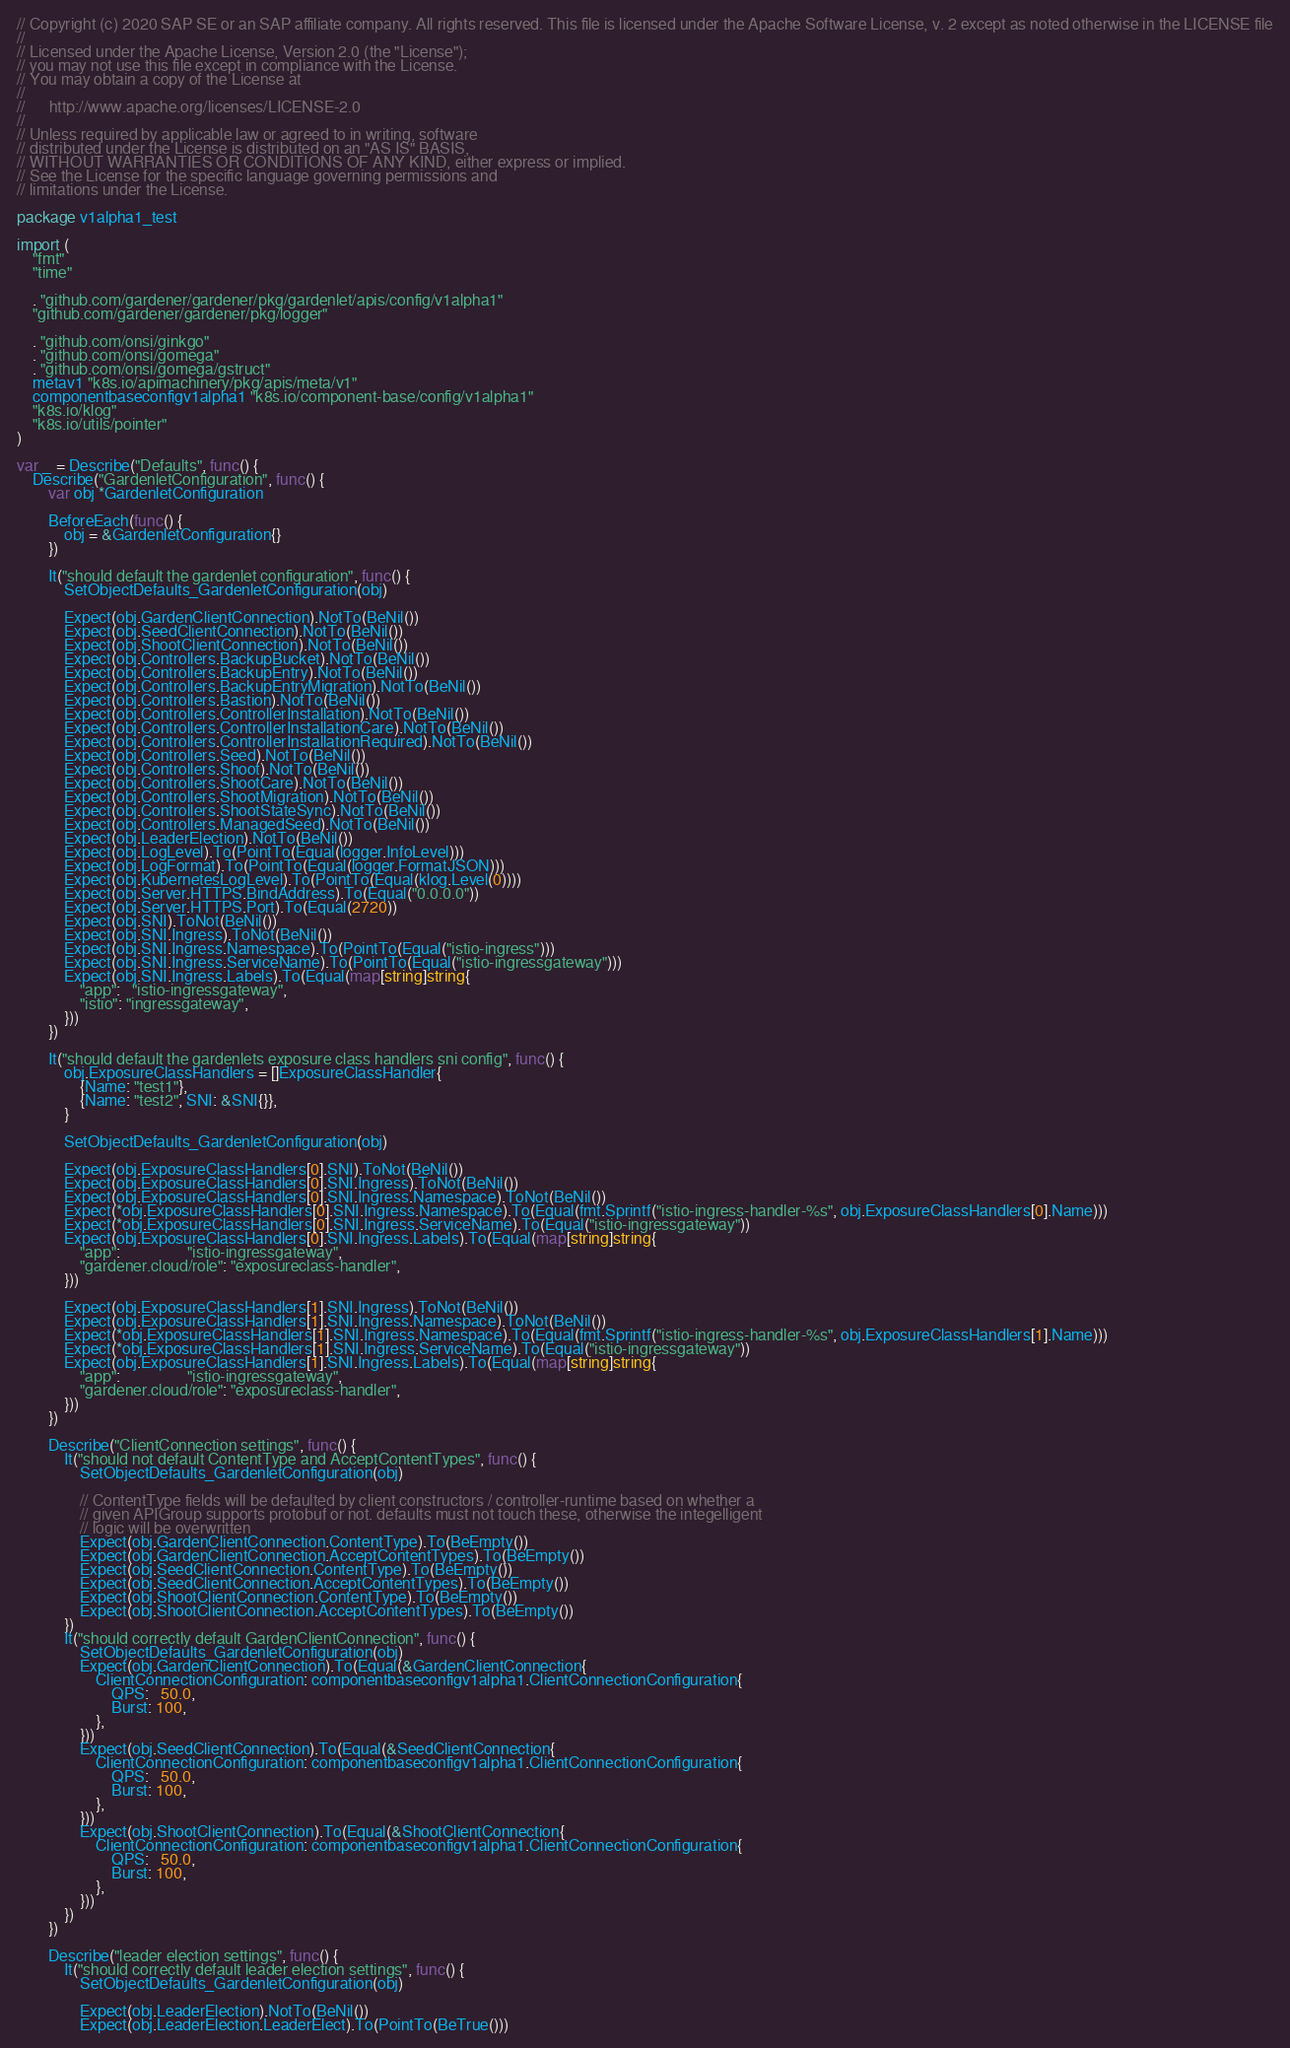Convert code to text. <code><loc_0><loc_0><loc_500><loc_500><_Go_>// Copyright (c) 2020 SAP SE or an SAP affiliate company. All rights reserved. This file is licensed under the Apache Software License, v. 2 except as noted otherwise in the LICENSE file
//
// Licensed under the Apache License, Version 2.0 (the "License");
// you may not use this file except in compliance with the License.
// You may obtain a copy of the License at
//
//      http://www.apache.org/licenses/LICENSE-2.0
//
// Unless required by applicable law or agreed to in writing, software
// distributed under the License is distributed on an "AS IS" BASIS,
// WITHOUT WARRANTIES OR CONDITIONS OF ANY KIND, either express or implied.
// See the License for the specific language governing permissions and
// limitations under the License.

package v1alpha1_test

import (
	"fmt"
	"time"

	. "github.com/gardener/gardener/pkg/gardenlet/apis/config/v1alpha1"
	"github.com/gardener/gardener/pkg/logger"

	. "github.com/onsi/ginkgo"
	. "github.com/onsi/gomega"
	. "github.com/onsi/gomega/gstruct"
	metav1 "k8s.io/apimachinery/pkg/apis/meta/v1"
	componentbaseconfigv1alpha1 "k8s.io/component-base/config/v1alpha1"
	"k8s.io/klog"
	"k8s.io/utils/pointer"
)

var _ = Describe("Defaults", func() {
	Describe("GardenletConfiguration", func() {
		var obj *GardenletConfiguration

		BeforeEach(func() {
			obj = &GardenletConfiguration{}
		})

		It("should default the gardenlet configuration", func() {
			SetObjectDefaults_GardenletConfiguration(obj)

			Expect(obj.GardenClientConnection).NotTo(BeNil())
			Expect(obj.SeedClientConnection).NotTo(BeNil())
			Expect(obj.ShootClientConnection).NotTo(BeNil())
			Expect(obj.Controllers.BackupBucket).NotTo(BeNil())
			Expect(obj.Controllers.BackupEntry).NotTo(BeNil())
			Expect(obj.Controllers.BackupEntryMigration).NotTo(BeNil())
			Expect(obj.Controllers.Bastion).NotTo(BeNil())
			Expect(obj.Controllers.ControllerInstallation).NotTo(BeNil())
			Expect(obj.Controllers.ControllerInstallationCare).NotTo(BeNil())
			Expect(obj.Controllers.ControllerInstallationRequired).NotTo(BeNil())
			Expect(obj.Controllers.Seed).NotTo(BeNil())
			Expect(obj.Controllers.Shoot).NotTo(BeNil())
			Expect(obj.Controllers.ShootCare).NotTo(BeNil())
			Expect(obj.Controllers.ShootMigration).NotTo(BeNil())
			Expect(obj.Controllers.ShootStateSync).NotTo(BeNil())
			Expect(obj.Controllers.ManagedSeed).NotTo(BeNil())
			Expect(obj.LeaderElection).NotTo(BeNil())
			Expect(obj.LogLevel).To(PointTo(Equal(logger.InfoLevel)))
			Expect(obj.LogFormat).To(PointTo(Equal(logger.FormatJSON)))
			Expect(obj.KubernetesLogLevel).To(PointTo(Equal(klog.Level(0))))
			Expect(obj.Server.HTTPS.BindAddress).To(Equal("0.0.0.0"))
			Expect(obj.Server.HTTPS.Port).To(Equal(2720))
			Expect(obj.SNI).ToNot(BeNil())
			Expect(obj.SNI.Ingress).ToNot(BeNil())
			Expect(obj.SNI.Ingress.Namespace).To(PointTo(Equal("istio-ingress")))
			Expect(obj.SNI.Ingress.ServiceName).To(PointTo(Equal("istio-ingressgateway")))
			Expect(obj.SNI.Ingress.Labels).To(Equal(map[string]string{
				"app":   "istio-ingressgateway",
				"istio": "ingressgateway",
			}))
		})

		It("should default the gardenlets exposure class handlers sni config", func() {
			obj.ExposureClassHandlers = []ExposureClassHandler{
				{Name: "test1"},
				{Name: "test2", SNI: &SNI{}},
			}

			SetObjectDefaults_GardenletConfiguration(obj)

			Expect(obj.ExposureClassHandlers[0].SNI).ToNot(BeNil())
			Expect(obj.ExposureClassHandlers[0].SNI.Ingress).ToNot(BeNil())
			Expect(obj.ExposureClassHandlers[0].SNI.Ingress.Namespace).ToNot(BeNil())
			Expect(*obj.ExposureClassHandlers[0].SNI.Ingress.Namespace).To(Equal(fmt.Sprintf("istio-ingress-handler-%s", obj.ExposureClassHandlers[0].Name)))
			Expect(*obj.ExposureClassHandlers[0].SNI.Ingress.ServiceName).To(Equal("istio-ingressgateway"))
			Expect(obj.ExposureClassHandlers[0].SNI.Ingress.Labels).To(Equal(map[string]string{
				"app":                 "istio-ingressgateway",
				"gardener.cloud/role": "exposureclass-handler",
			}))

			Expect(obj.ExposureClassHandlers[1].SNI.Ingress).ToNot(BeNil())
			Expect(obj.ExposureClassHandlers[1].SNI.Ingress.Namespace).ToNot(BeNil())
			Expect(*obj.ExposureClassHandlers[1].SNI.Ingress.Namespace).To(Equal(fmt.Sprintf("istio-ingress-handler-%s", obj.ExposureClassHandlers[1].Name)))
			Expect(*obj.ExposureClassHandlers[1].SNI.Ingress.ServiceName).To(Equal("istio-ingressgateway"))
			Expect(obj.ExposureClassHandlers[1].SNI.Ingress.Labels).To(Equal(map[string]string{
				"app":                 "istio-ingressgateway",
				"gardener.cloud/role": "exposureclass-handler",
			}))
		})

		Describe("ClientConnection settings", func() {
			It("should not default ContentType and AcceptContentTypes", func() {
				SetObjectDefaults_GardenletConfiguration(obj)

				// ContentType fields will be defaulted by client constructors / controller-runtime based on whether a
				// given APIGroup supports protobuf or not. defaults must not touch these, otherwise the integelligent
				// logic will be overwritten
				Expect(obj.GardenClientConnection.ContentType).To(BeEmpty())
				Expect(obj.GardenClientConnection.AcceptContentTypes).To(BeEmpty())
				Expect(obj.SeedClientConnection.ContentType).To(BeEmpty())
				Expect(obj.SeedClientConnection.AcceptContentTypes).To(BeEmpty())
				Expect(obj.ShootClientConnection.ContentType).To(BeEmpty())
				Expect(obj.ShootClientConnection.AcceptContentTypes).To(BeEmpty())
			})
			It("should correctly default GardenClientConnection", func() {
				SetObjectDefaults_GardenletConfiguration(obj)
				Expect(obj.GardenClientConnection).To(Equal(&GardenClientConnection{
					ClientConnectionConfiguration: componentbaseconfigv1alpha1.ClientConnectionConfiguration{
						QPS:   50.0,
						Burst: 100,
					},
				}))
				Expect(obj.SeedClientConnection).To(Equal(&SeedClientConnection{
					ClientConnectionConfiguration: componentbaseconfigv1alpha1.ClientConnectionConfiguration{
						QPS:   50.0,
						Burst: 100,
					},
				}))
				Expect(obj.ShootClientConnection).To(Equal(&ShootClientConnection{
					ClientConnectionConfiguration: componentbaseconfigv1alpha1.ClientConnectionConfiguration{
						QPS:   50.0,
						Burst: 100,
					},
				}))
			})
		})

		Describe("leader election settings", func() {
			It("should correctly default leader election settings", func() {
				SetObjectDefaults_GardenletConfiguration(obj)

				Expect(obj.LeaderElection).NotTo(BeNil())
				Expect(obj.LeaderElection.LeaderElect).To(PointTo(BeTrue()))</code> 